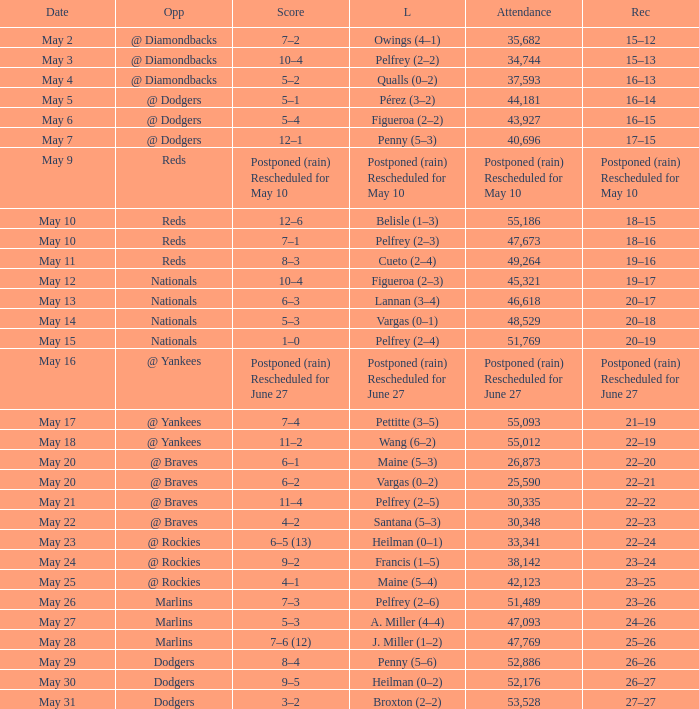Record of 22–20 involved what score? 6–1. Can you give me this table as a dict? {'header': ['Date', 'Opp', 'Score', 'L', 'Attendance', 'Rec'], 'rows': [['May 2', '@ Diamondbacks', '7–2', 'Owings (4–1)', '35,682', '15–12'], ['May 3', '@ Diamondbacks', '10–4', 'Pelfrey (2–2)', '34,744', '15–13'], ['May 4', '@ Diamondbacks', '5–2', 'Qualls (0–2)', '37,593', '16–13'], ['May 5', '@ Dodgers', '5–1', 'Pérez (3–2)', '44,181', '16–14'], ['May 6', '@ Dodgers', '5–4', 'Figueroa (2–2)', '43,927', '16–15'], ['May 7', '@ Dodgers', '12–1', 'Penny (5–3)', '40,696', '17–15'], ['May 9', 'Reds', 'Postponed (rain) Rescheduled for May 10', 'Postponed (rain) Rescheduled for May 10', 'Postponed (rain) Rescheduled for May 10', 'Postponed (rain) Rescheduled for May 10'], ['May 10', 'Reds', '12–6', 'Belisle (1–3)', '55,186', '18–15'], ['May 10', 'Reds', '7–1', 'Pelfrey (2–3)', '47,673', '18–16'], ['May 11', 'Reds', '8–3', 'Cueto (2–4)', '49,264', '19–16'], ['May 12', 'Nationals', '10–4', 'Figueroa (2–3)', '45,321', '19–17'], ['May 13', 'Nationals', '6–3', 'Lannan (3–4)', '46,618', '20–17'], ['May 14', 'Nationals', '5–3', 'Vargas (0–1)', '48,529', '20–18'], ['May 15', 'Nationals', '1–0', 'Pelfrey (2–4)', '51,769', '20–19'], ['May 16', '@ Yankees', 'Postponed (rain) Rescheduled for June 27', 'Postponed (rain) Rescheduled for June 27', 'Postponed (rain) Rescheduled for June 27', 'Postponed (rain) Rescheduled for June 27'], ['May 17', '@ Yankees', '7–4', 'Pettitte (3–5)', '55,093', '21–19'], ['May 18', '@ Yankees', '11–2', 'Wang (6–2)', '55,012', '22–19'], ['May 20', '@ Braves', '6–1', 'Maine (5–3)', '26,873', '22–20'], ['May 20', '@ Braves', '6–2', 'Vargas (0–2)', '25,590', '22–21'], ['May 21', '@ Braves', '11–4', 'Pelfrey (2–5)', '30,335', '22–22'], ['May 22', '@ Braves', '4–2', 'Santana (5–3)', '30,348', '22–23'], ['May 23', '@ Rockies', '6–5 (13)', 'Heilman (0–1)', '33,341', '22–24'], ['May 24', '@ Rockies', '9–2', 'Francis (1–5)', '38,142', '23–24'], ['May 25', '@ Rockies', '4–1', 'Maine (5–4)', '42,123', '23–25'], ['May 26', 'Marlins', '7–3', 'Pelfrey (2–6)', '51,489', '23–26'], ['May 27', 'Marlins', '5–3', 'A. Miller (4–4)', '47,093', '24–26'], ['May 28', 'Marlins', '7–6 (12)', 'J. Miller (1–2)', '47,769', '25–26'], ['May 29', 'Dodgers', '8–4', 'Penny (5–6)', '52,886', '26–26'], ['May 30', 'Dodgers', '9–5', 'Heilman (0–2)', '52,176', '26–27'], ['May 31', 'Dodgers', '3–2', 'Broxton (2–2)', '53,528', '27–27']]} 